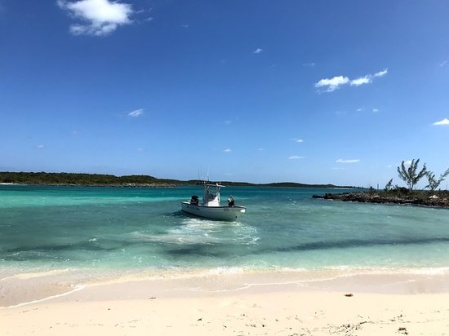Imagine you are on the beach watching the boat. What's the atmosphere like? Standing on the sandy beach, you're greeted by a gentle, warm breeze that carries the salty scent of the ocean. The rhythmic sound of waves lapping against the shore creates a soothing backdrop, while the occasional cry of seagulls adds to the idyllic atmosphere. The sun shines brightly, casting a golden hue on the sand and sparkling on the turquoise waters. Nearby, the rustling of leaves from the scattered trees and bushes further enhances the sense of peace and tranquility. It's a perfect moment of serenity, where time seems to slow down, allowing you to fully immerse yourself in the natural beauty surrounding you. What do you think the people in the boat are feeling right now? The people in the boat are likely experiencing a sense of contentment and joy. The calm and inviting waters, combined with the clear blue sky, create an uplifting mood. They might be feeling a blend of excitement and relaxation, appreciating the freedom and adventure that comes with being out at sea. There’s a shared sense of camaraderie among them, as they enjoy their time away from the hustle and bustle of daily life. The serene landscape and perfect weather amplify their enjoyment, making this a memorable and joyous outing for everyone on board. 